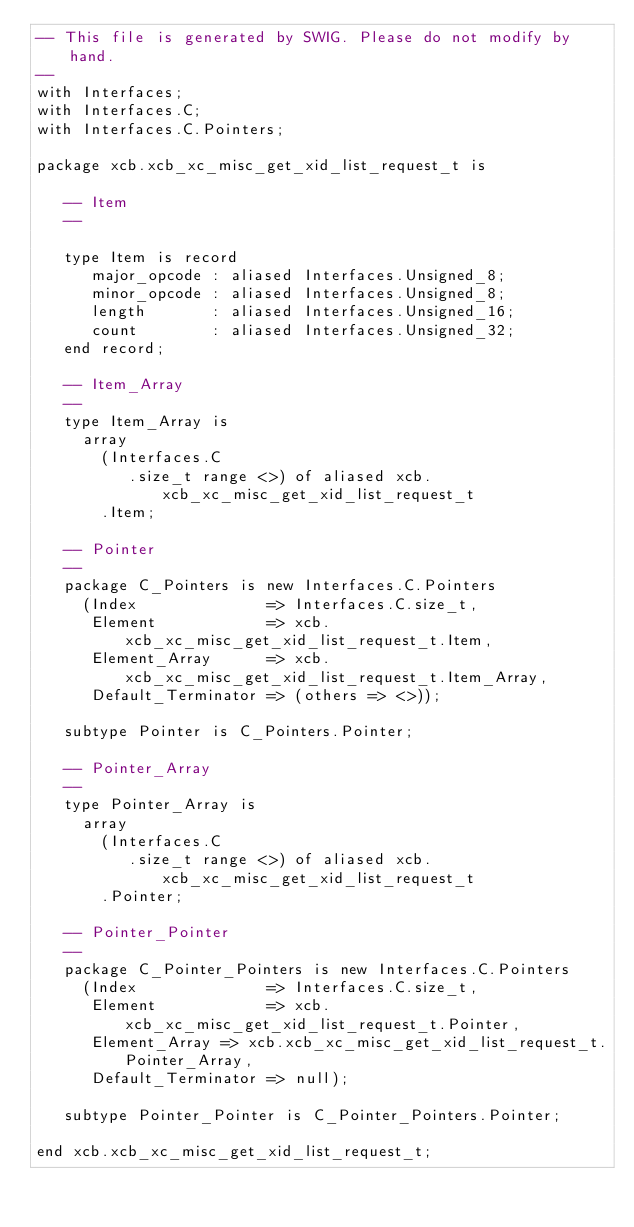<code> <loc_0><loc_0><loc_500><loc_500><_Ada_>-- This file is generated by SWIG. Please do not modify by hand.
--
with Interfaces;
with Interfaces.C;
with Interfaces.C.Pointers;

package xcb.xcb_xc_misc_get_xid_list_request_t is

   -- Item
   --

   type Item is record
      major_opcode : aliased Interfaces.Unsigned_8;
      minor_opcode : aliased Interfaces.Unsigned_8;
      length       : aliased Interfaces.Unsigned_16;
      count        : aliased Interfaces.Unsigned_32;
   end record;

   -- Item_Array
   --
   type Item_Array is
     array
       (Interfaces.C
          .size_t range <>) of aliased xcb.xcb_xc_misc_get_xid_list_request_t
       .Item;

   -- Pointer
   --
   package C_Pointers is new Interfaces.C.Pointers
     (Index              => Interfaces.C.size_t,
      Element            => xcb.xcb_xc_misc_get_xid_list_request_t.Item,
      Element_Array      => xcb.xcb_xc_misc_get_xid_list_request_t.Item_Array,
      Default_Terminator => (others => <>));

   subtype Pointer is C_Pointers.Pointer;

   -- Pointer_Array
   --
   type Pointer_Array is
     array
       (Interfaces.C
          .size_t range <>) of aliased xcb.xcb_xc_misc_get_xid_list_request_t
       .Pointer;

   -- Pointer_Pointer
   --
   package C_Pointer_Pointers is new Interfaces.C.Pointers
     (Index              => Interfaces.C.size_t,
      Element            => xcb.xcb_xc_misc_get_xid_list_request_t.Pointer,
      Element_Array => xcb.xcb_xc_misc_get_xid_list_request_t.Pointer_Array,
      Default_Terminator => null);

   subtype Pointer_Pointer is C_Pointer_Pointers.Pointer;

end xcb.xcb_xc_misc_get_xid_list_request_t;
</code> 